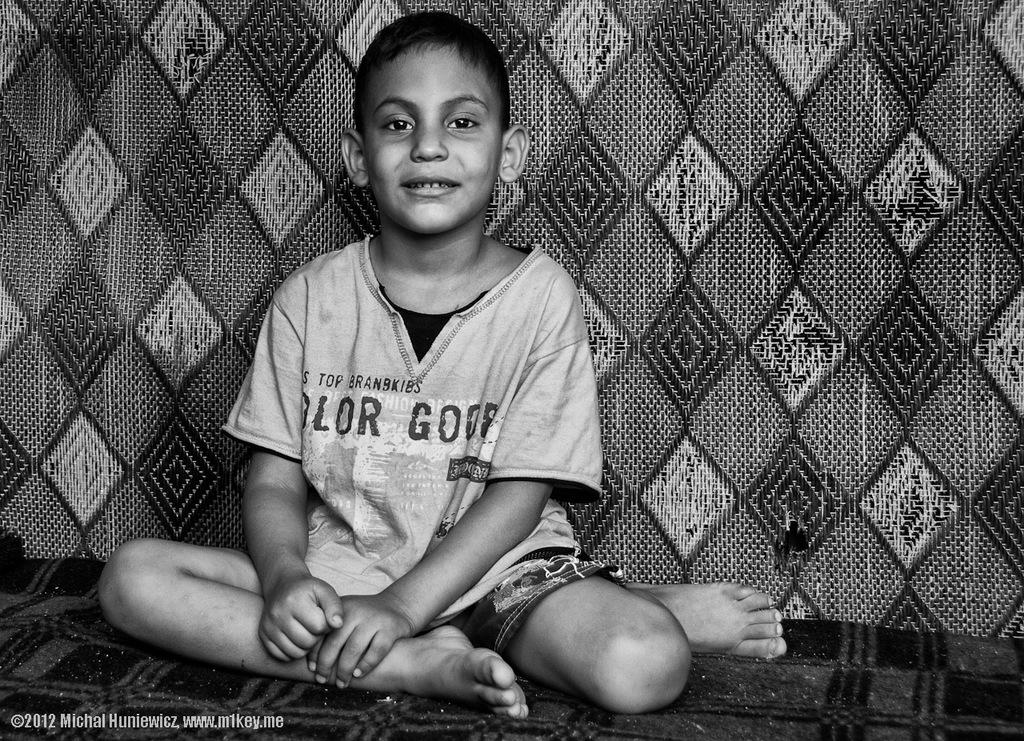What is the main subject of the image? There is a child in the image. What is the child doing in the image? The child is sitting on a bed and smiling. What else can be seen in the image? There is a blanket visible in the image. What type of hydrant can be seen in the image? There is no hydrant present in the image. What is the child's level of fear in the image? The child is smiling in the image, which suggests they are not afraid. 